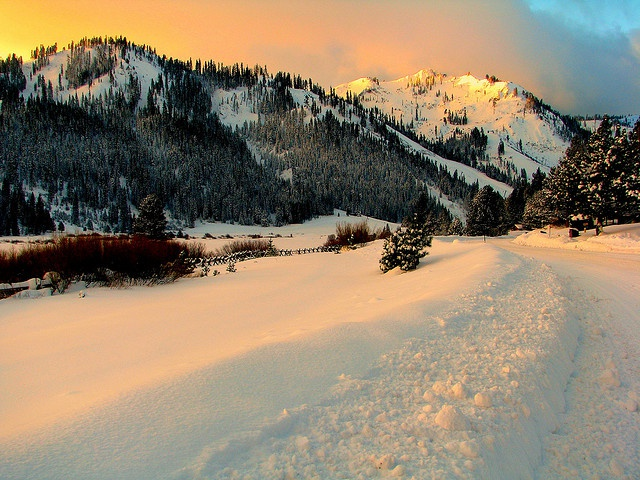Describe the objects in this image and their specific colors. I can see various objects in this image with different colors. 